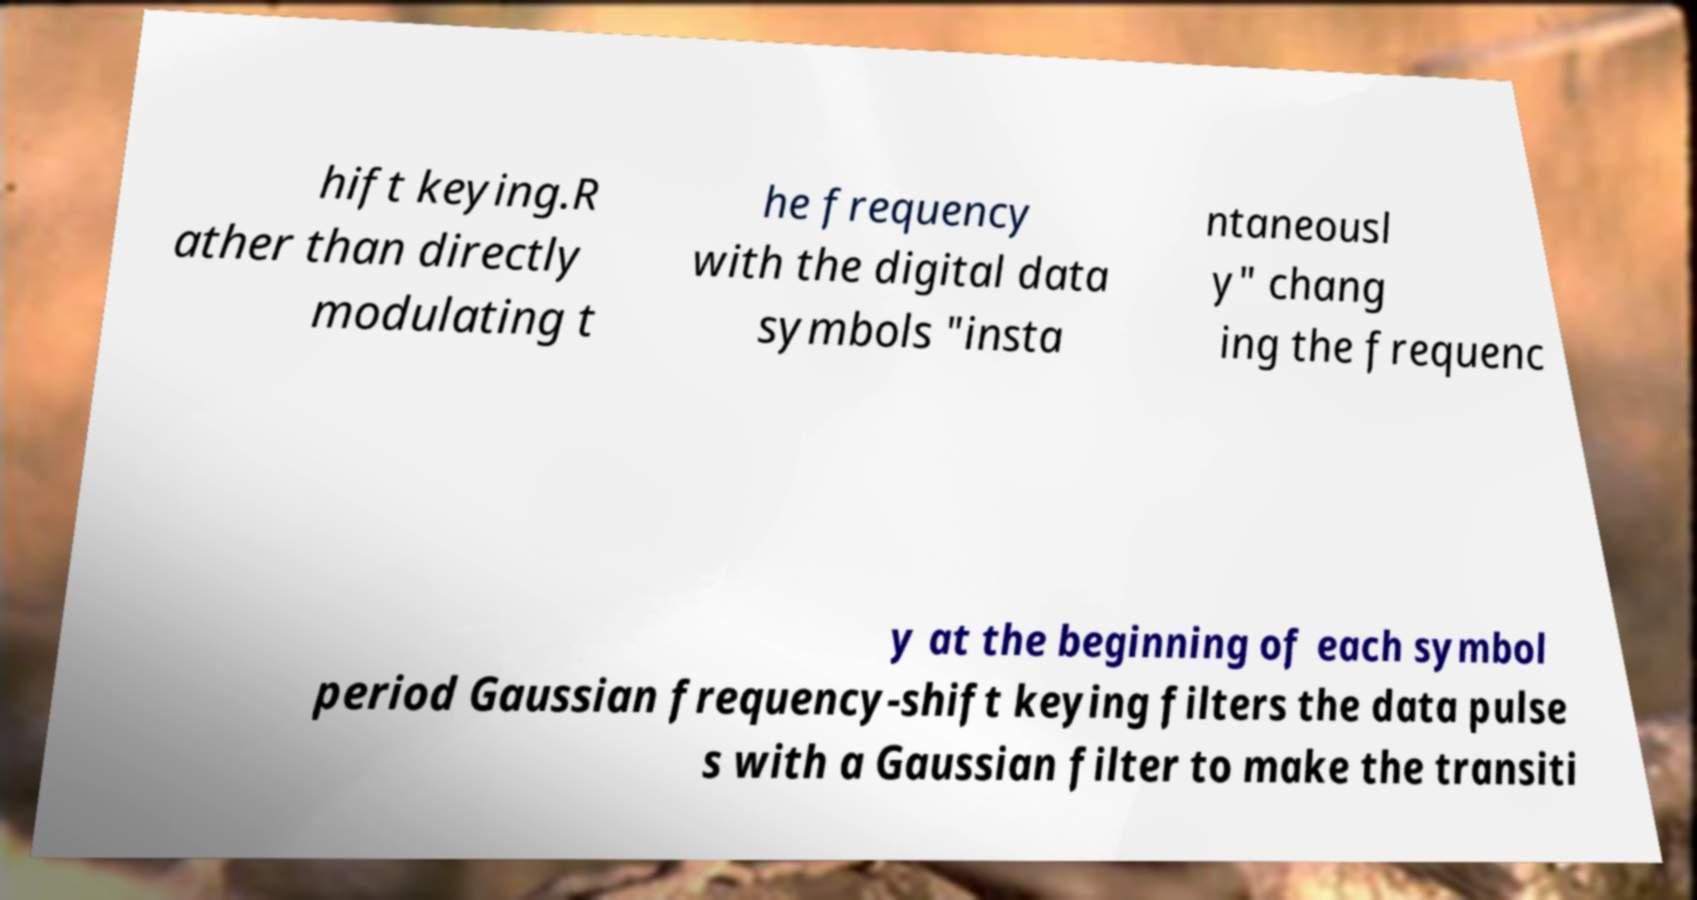Could you extract and type out the text from this image? hift keying.R ather than directly modulating t he frequency with the digital data symbols "insta ntaneousl y" chang ing the frequenc y at the beginning of each symbol period Gaussian frequency-shift keying filters the data pulse s with a Gaussian filter to make the transiti 